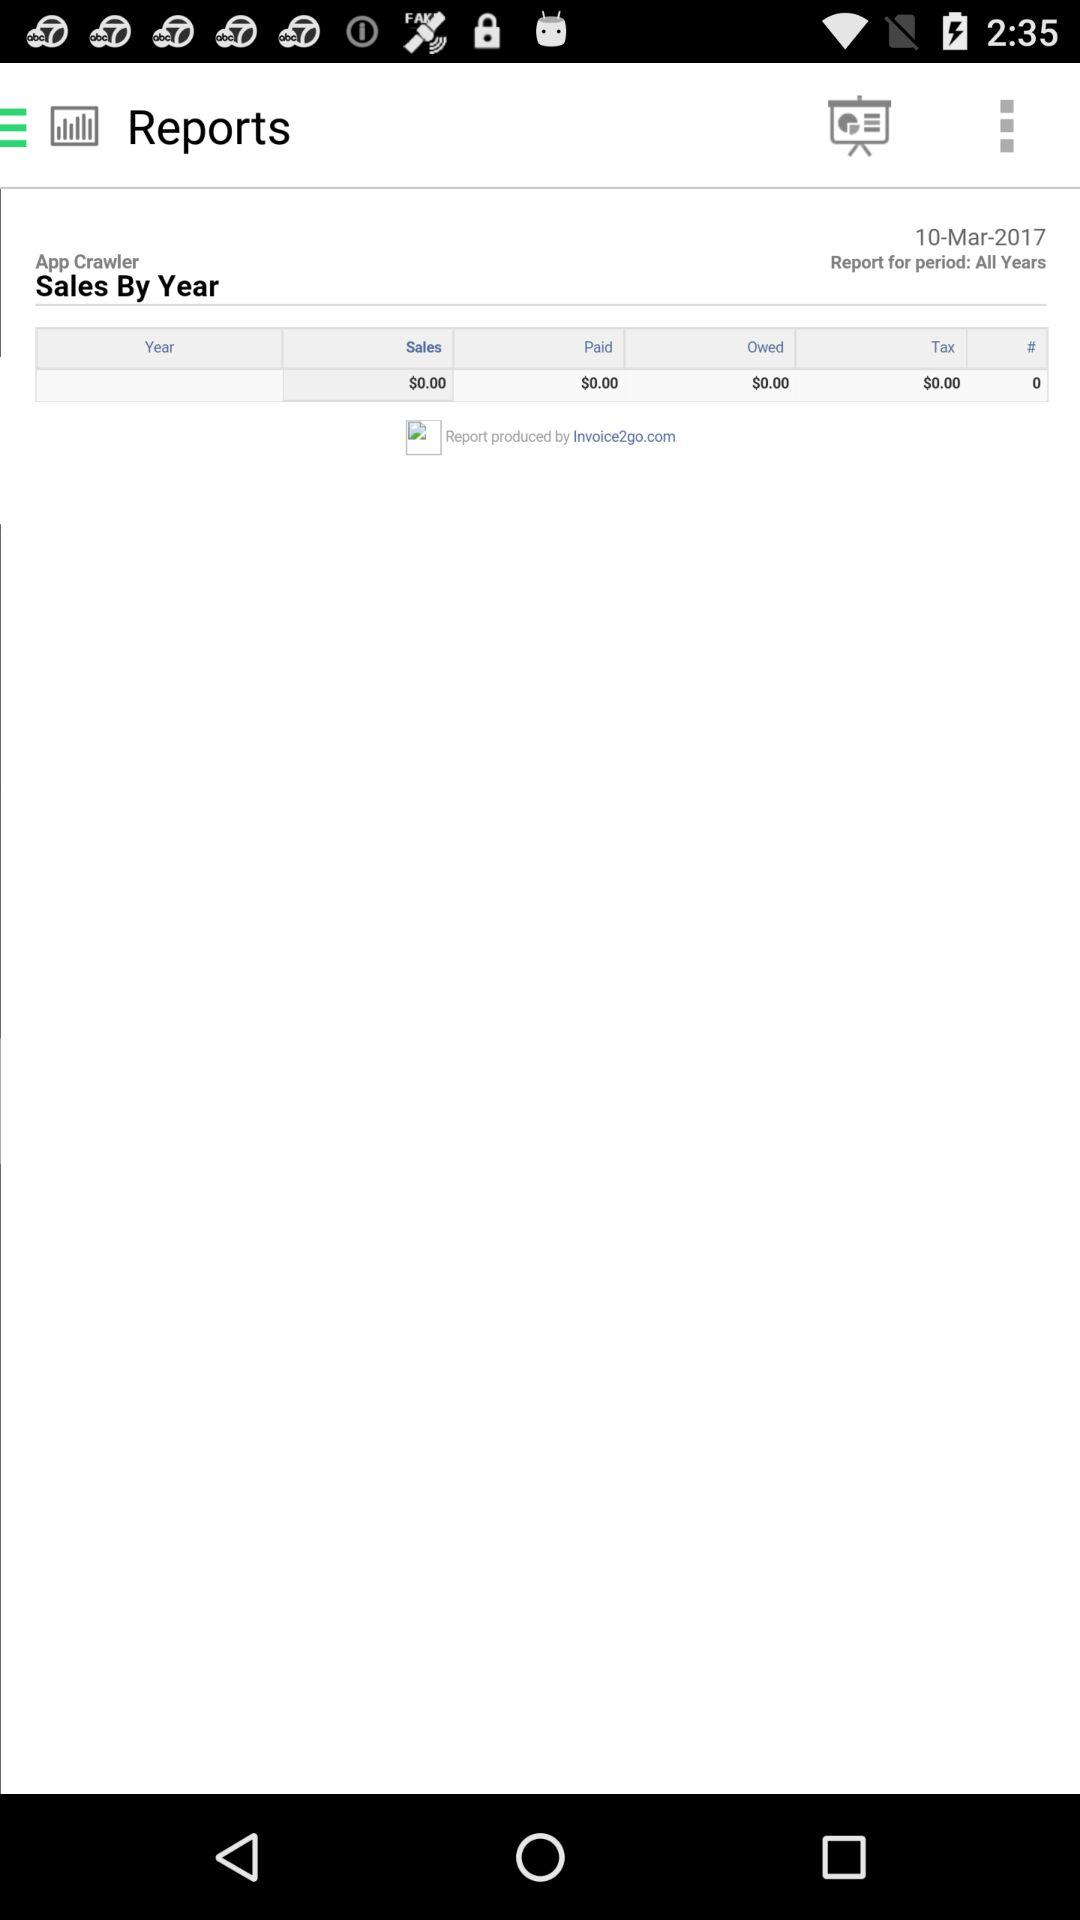How many years are included in this report?
Answer the question using a single word or phrase. All Years 